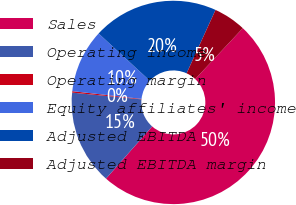<chart> <loc_0><loc_0><loc_500><loc_500><pie_chart><fcel>Sales<fcel>Operating income<fcel>Operating margin<fcel>Equity affiliates' income<fcel>Adjusted EBITDA<fcel>Adjusted EBITDA margin<nl><fcel>49.55%<fcel>15.02%<fcel>0.23%<fcel>10.09%<fcel>19.95%<fcel>5.16%<nl></chart> 